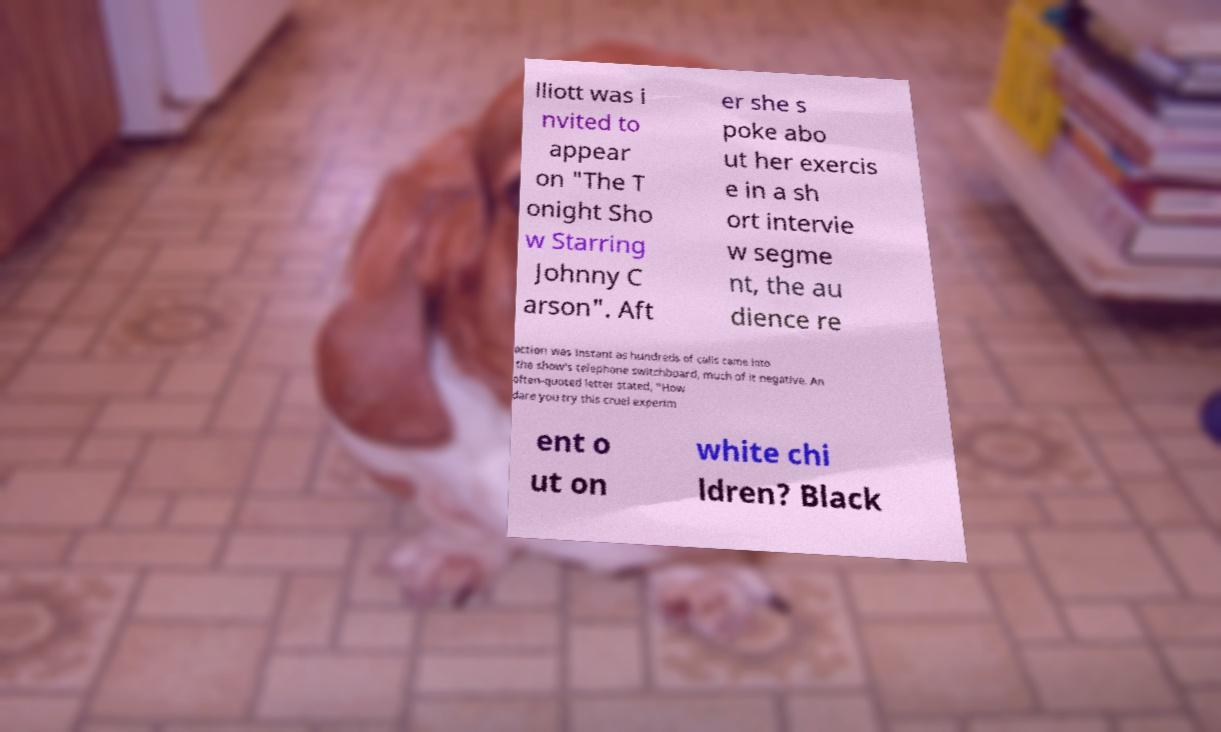Can you read and provide the text displayed in the image?This photo seems to have some interesting text. Can you extract and type it out for me? lliott was i nvited to appear on "The T onight Sho w Starring Johnny C arson". Aft er she s poke abo ut her exercis e in a sh ort intervie w segme nt, the au dience re action was instant as hundreds of calls came into the show's telephone switchboard, much of it negative. An often-quoted letter stated, "How dare you try this cruel experim ent o ut on white chi ldren? Black 